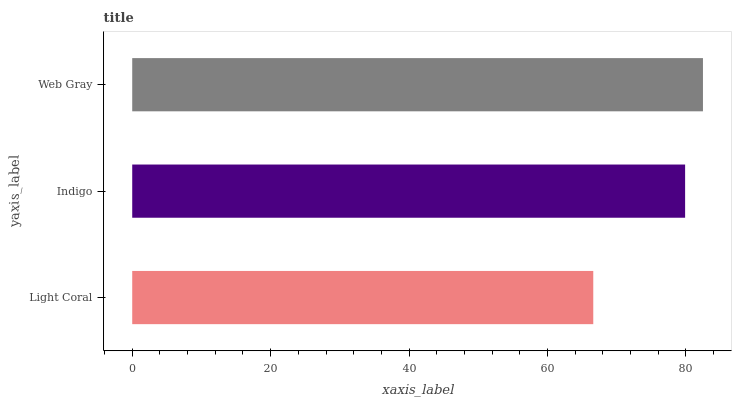Is Light Coral the minimum?
Answer yes or no. Yes. Is Web Gray the maximum?
Answer yes or no. Yes. Is Indigo the minimum?
Answer yes or no. No. Is Indigo the maximum?
Answer yes or no. No. Is Indigo greater than Light Coral?
Answer yes or no. Yes. Is Light Coral less than Indigo?
Answer yes or no. Yes. Is Light Coral greater than Indigo?
Answer yes or no. No. Is Indigo less than Light Coral?
Answer yes or no. No. Is Indigo the high median?
Answer yes or no. Yes. Is Indigo the low median?
Answer yes or no. Yes. Is Web Gray the high median?
Answer yes or no. No. Is Web Gray the low median?
Answer yes or no. No. 